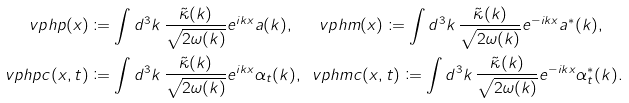<formula> <loc_0><loc_0><loc_500><loc_500>\ v p h p ( x ) & \coloneqq \int d ^ { 3 } k \, \frac { \tilde { \kappa } ( k ) } { \sqrt { 2 \omega ( k ) } } e ^ { i k x } a ( k ) , \quad \, \ v p h m ( x ) \coloneqq \int d ^ { 3 } k \, \frac { \tilde { \kappa } ( k ) } { \sqrt { 2 \omega ( k ) } } e ^ { - i k x } a ^ { * } ( k ) , \\ \ v p h p c ( x , t ) & \coloneqq \int d ^ { 3 } k \, \frac { \tilde { \kappa } ( k ) } { \sqrt { 2 \omega ( k ) } } e ^ { i k x } \alpha _ { t } ( k ) , \, \ v p h m c ( x , t ) \coloneqq \int d ^ { 3 } k \, \frac { \tilde { \kappa } ( k ) } { \sqrt { 2 \omega ( k ) } } e ^ { - i k x } \alpha _ { t } ^ { * } ( k ) .</formula> 